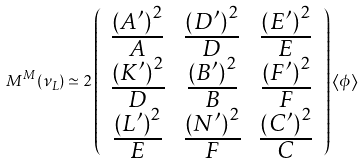<formula> <loc_0><loc_0><loc_500><loc_500>M ^ { M } ( \nu _ { L } ) \simeq 2 \left ( \begin{array} { c c c } \frac { \left ( A ^ { \prime } \right ) ^ { 2 } } { A } & \frac { \left ( D ^ { \prime } \right ) ^ { 2 } } { D } & \frac { \left ( E ^ { \prime } \right ) ^ { 2 } } { E } \\ \frac { \left ( K ^ { \prime } \right ) ^ { 2 } } { D } & \frac { \left ( B ^ { \prime } \right ) ^ { 2 } } { B } & \frac { \left ( F ^ { \prime } \right ) ^ { 2 } } { F } \\ \frac { \left ( L ^ { \prime } \right ) ^ { 2 } } { E } & \frac { \left ( N ^ { \prime } \right ) ^ { 2 } } { F } & \frac { \left ( C ^ { \prime } \right ) ^ { 2 } } { C } \end{array} \right ) \left \langle \phi \right \rangle</formula> 